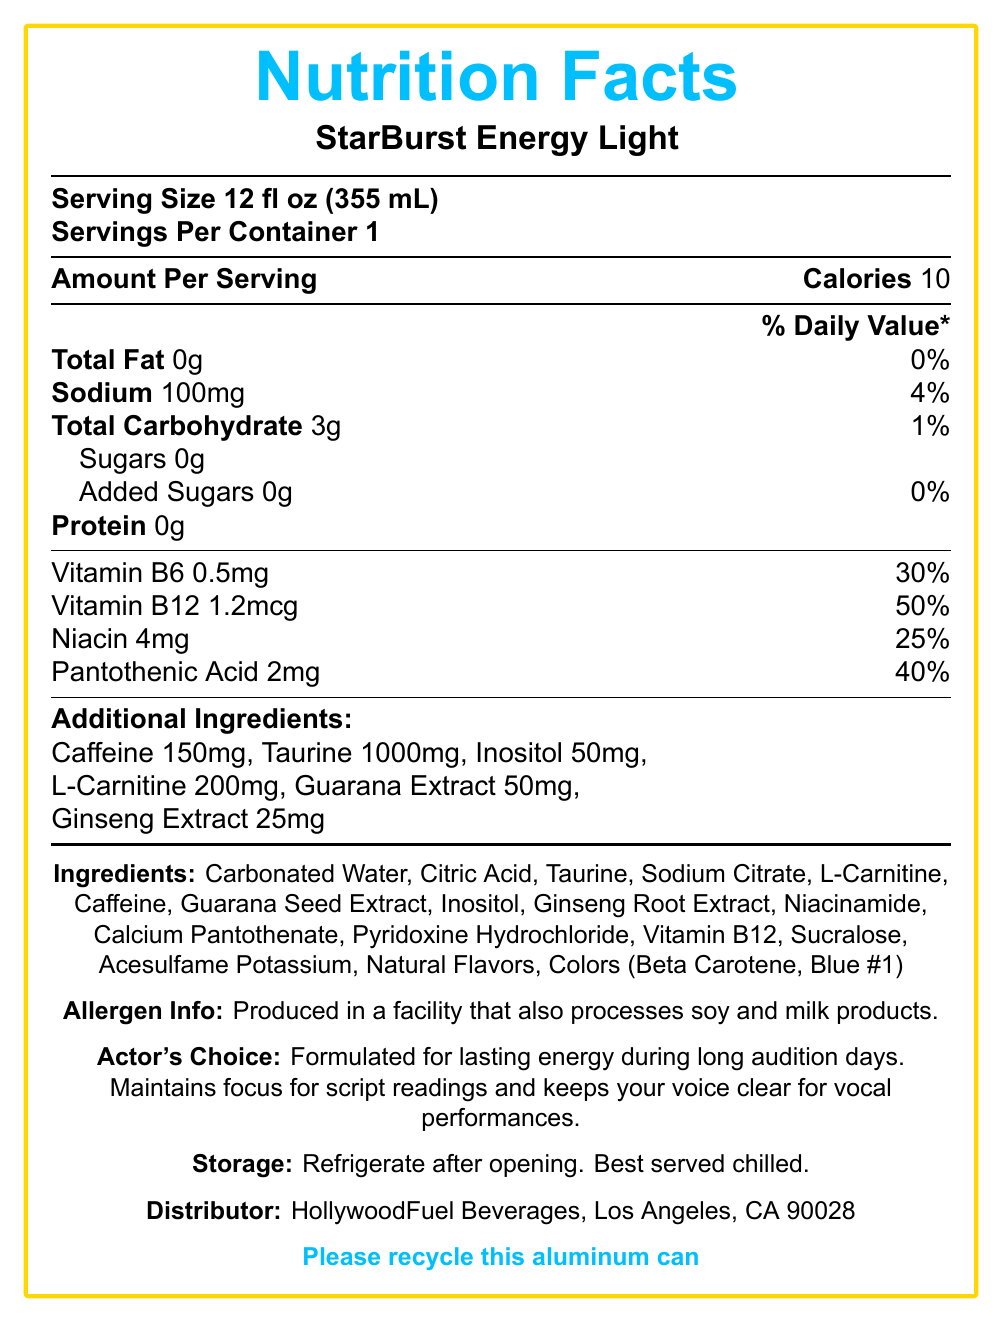What is the total calorie content per serving of StarBurst Energy Light? The document states that the calorie content per serving is 10 calories.
Answer: 10 calories What is the serving size of StarBurst Energy Light? The serving size is listed as 12 fl oz (355 mL) in the document.
Answer: 12 fl oz (355 mL) How much sodium is in each serving? The sodium content per serving is 100mg as shown in the document.
Answer: 100mg What percentage of daily value does Vitamin B12 provide? The document mentions that Vitamin B12 provides 50% of the daily value per serving.
Answer: 50% Name three active ingredients found in StarBurst Energy Light. Caffeine, Taurine, and L-Carnitine are listed among the active ingredients.
Answer: Caffeine, Taurine, L-Carnitine Does StarBurst Energy Light contain any added sugars? The document clearly states that there are 0g of added sugars in the product.
Answer: No Is there any protein in StarBurst Energy Light? The document indicates that the protein content is 0g.
Answer: No What is the main appeal of StarBurst Energy Light for actors? The document specifies that the product is formulated to provide lasting energy, maintain focus, and keep the voice clear.
Answer: Lasting energy without jitters, maintaining focus, clear voice How many total carbohydrates are in a single serving? The amount of total carbohydrates per serving is listed as 3g.
Answer: 3g Which of the following vitamins are included in StarBurst Energy Light? A. Vitamin C B. Vitamin B6 C. Vitamin D D. Vitamin B12 The document lists Vitamin B6 and Vitamin B12 among the nutrients provided by the drink.
Answer: B. Vitamin B6 and D. Vitamin B12 What is the recommended storage condition for StarBurst Energy Light? The document recommends refrigerating the product after opening and serving it chilled.
Answer: Refrigerate after opening. Best served chilled. True or False: StarBurst Energy Light contains artificial colors. The document lists Colors (Beta Carotene, Blue #1) among the ingredients, indicating the presence of artificial colors.
Answer: True Provide a summary of the document. The document provides detailed nutrition information, ingredients, allergen info, and storage recommendations for StarBurst Energy Light, emphasizing its suitability for actors seeking lasting energy and focus during auditions.
Answer: StarBurst Energy Light is a low-calorie energy drink tailored for actors, featuring 10 calories per 12 fl oz serving. It contains vitamins such as B6, B12, niacin, and pantothenic acid, along with active ingredients like caffeine, taurine, and L-carnitine for sustained energy and focus. The product has no added sugars or fats, and a sodium content of 100mg. It highlights its actor-friendly benefits, needs refrigeration after opening, and comes in a recyclable can. How much caffeine is in StarBurst Energy Light? The document lists the caffeine content as 150mg per serving.
Answer: 150mg What is the daily value percentage of Pantothenic Acid in StarBurst Energy Light? Pantothenic Acid provides 40% of the daily value per serving as per the document.
Answer: 40% Who is the distributor of StarBurst Energy Light? The document lists HollywoodFuel Beverages as the distributor.
Answer: HollywoodFuel Beverages, Los Angeles, CA 90028 What flavoring sweeteners are used in StarBurst Energy Light? The document lists Sucralose and Acesulfame Potassium as the sweeteners used in the product.
Answer: Sucralose, Acesulfame Potassium Could StarBurst Energy Light be consumed by someone with a soy or milk allergy without risk? The document states that the product is produced in a facility that processes soy and milk products; thus, it cannot be determined if it is entirely safe for individuals with such allergies without more specific information.
Answer: Cannot be determined 